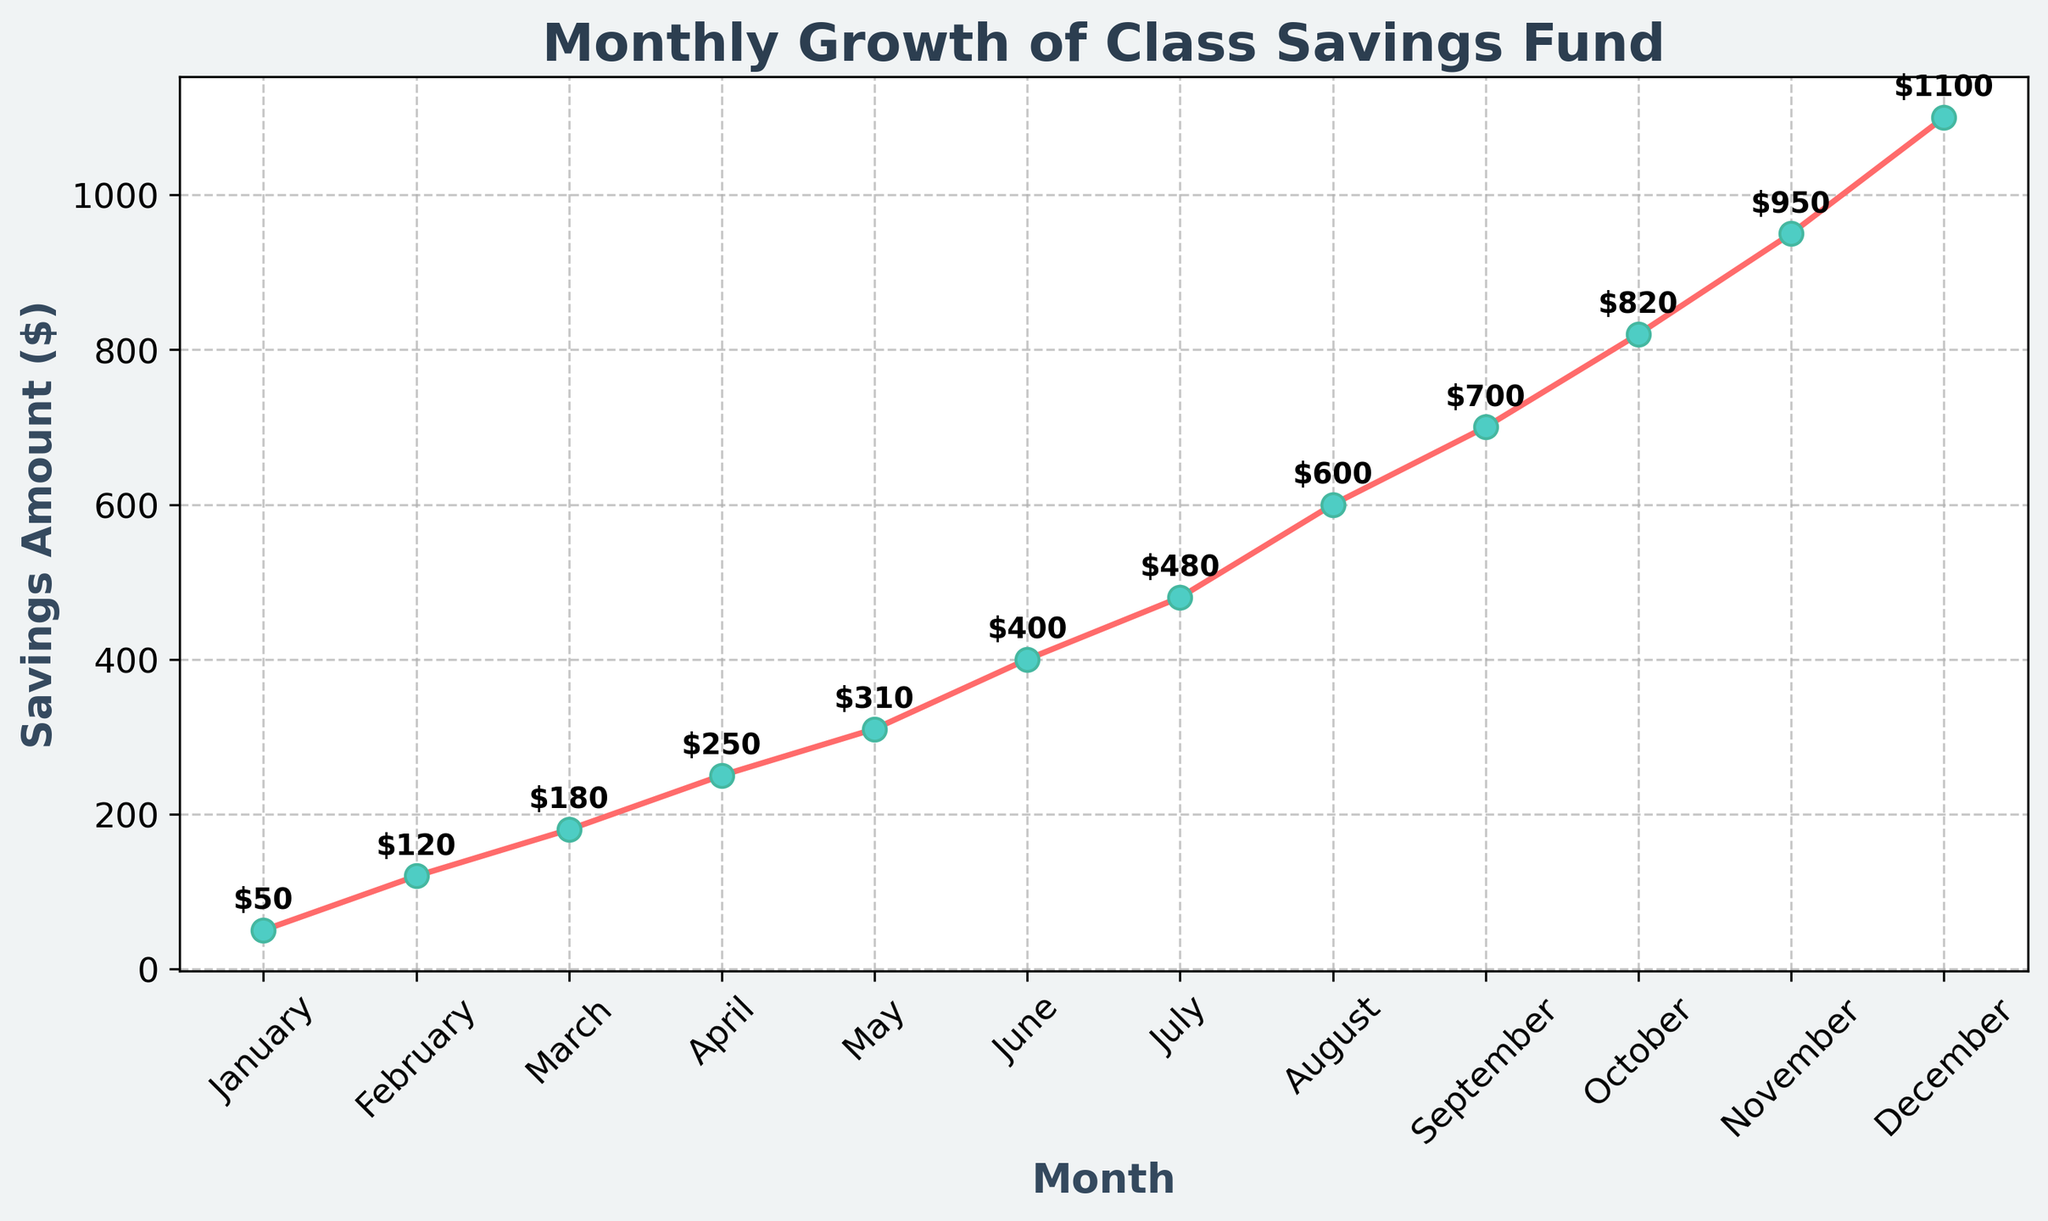What is the title of the figure? The title is located at the top of the figure in larger font size, making it easy to locate. The title summarizes what the figure is about.
Answer: Monthly Growth of Class Savings Fund What are the labels on the x-axis and y-axis? The x-axis label is at the bottom, and the y-axis label is on the left side of the plot. Both labels help in understanding what the axes represent. The x-axis shows the months, and the y-axis shows the savings amount in dollars.
Answer: x-axis: Month, y-axis: Savings Amount ($) In which month did the savings amount reach $820? Locate the point on the plot where the savings amount is marked as $820. Check the corresponding month on the x-axis directly below this point.
Answer: October What is the difference in savings between June and December? Look at the y-axis values for both June and December. Subtract the savings amount for June from that of December. The June savings are $400, and December savings are $1100. So, $1100 - $400 = $700.
Answer: $700 Which months show the highest and lowest savings amounts? Find the highest and lowest points on the plot. The highest point corresponds to December with $1100, and the lowest point corresponds to January with $50.
Answer: Highest: December, Lowest: January How many months did it take for the class savings fund to reach $600? Starting from January, count the number of months it takes for the savings amount to reach $600. The savings amount reaches $600 in August.
Answer: 8 months In which month did the savings increase by the largest amount? Calculate the difference in savings month-to-month and identify the month with the greatest increase. The largest jump appears between August ($600) and September ($700), a $100 increase.
Answer: September What is the total amount saved from January to April? Sum the savings from each month starting from January to April. $50 (Jan) + $120 (Feb) + $180 (Mar) + $250 (Apr) = $600.
Answer: $600 Compare the growth rate between the first half of the year (January to June) and the second half (July to December). Which period had more savings growth? Calculate the difference in savings from January to June and July to December. From January to June: $400 - $50 = $350. From July to December: $1100 - $480 = $620. The second half of the year shows more growth.
Answer: Second half What is the average savings amount for the entire year? Add up the savings amounts for each month and divide by 12. ($50 + $120 + $180 + $250 + $310 + $400 + $480 + $600 + $700 + $820 + $950 + $1100) / 12. The total is $5960, so the average is $5960 / 12 = $496.67.
Answer: $496.67 